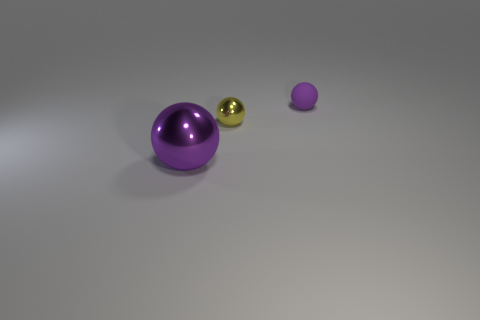Is there anything else that has the same material as the small purple ball?
Keep it short and to the point. No. Do the rubber thing and the big metal object have the same color?
Offer a terse response. Yes. There is a purple object in front of the yellow object; does it have the same shape as the yellow metal object?
Your answer should be very brief. Yes. How many spheres are both to the left of the small purple matte thing and behind the large metallic object?
Your answer should be compact. 1. What is the material of the yellow sphere?
Give a very brief answer. Metal. Are there any other things that have the same color as the tiny rubber thing?
Your answer should be compact. Yes. Is the small yellow sphere made of the same material as the tiny purple object?
Provide a succinct answer. No. There is a small object that is left of the purple object right of the purple shiny sphere; what number of tiny yellow shiny spheres are right of it?
Give a very brief answer. 0. What number of purple objects are there?
Make the answer very short. 2. Is the number of small objects that are in front of the tiny purple matte ball less than the number of things on the right side of the big ball?
Provide a short and direct response. Yes. 